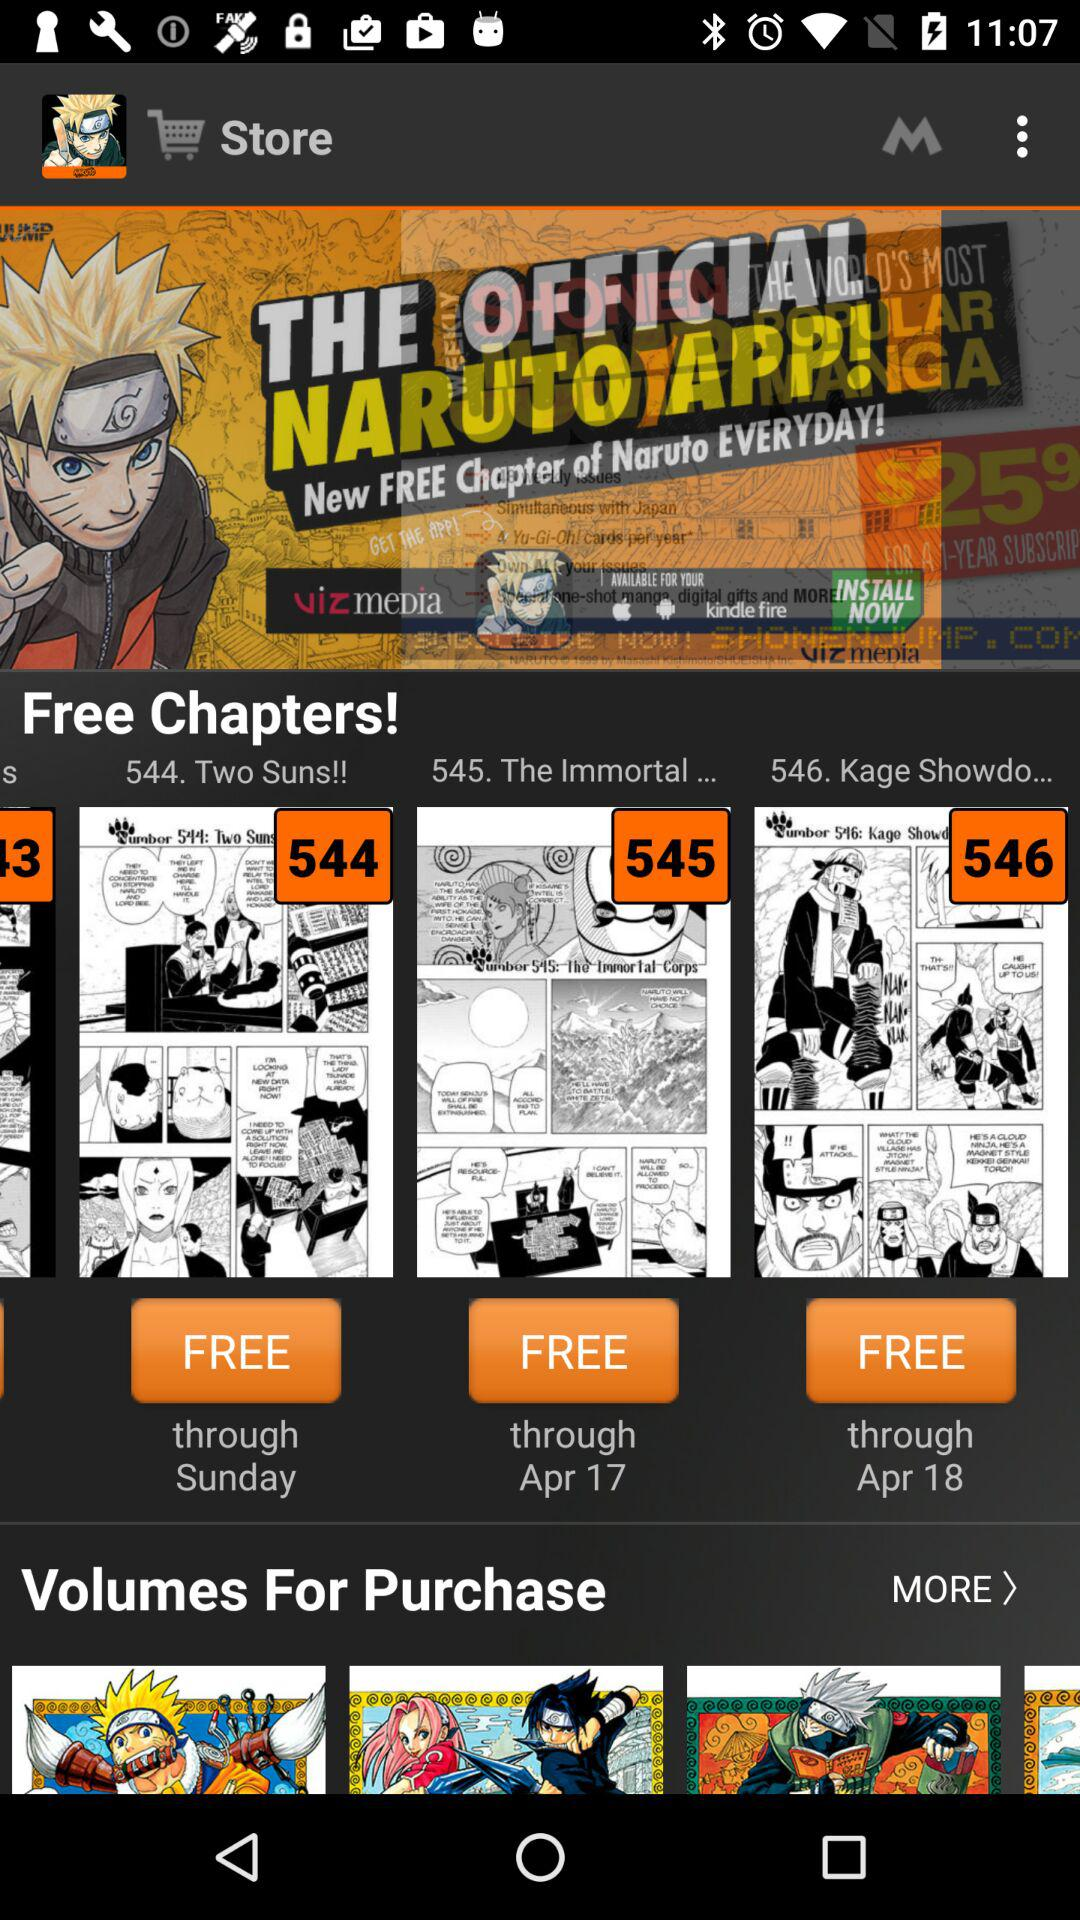How many chapters are free?
Answer the question using a single word or phrase. 3 